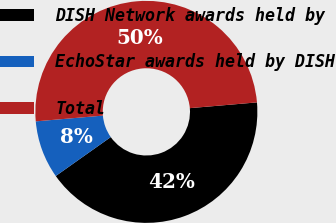Convert chart to OTSL. <chart><loc_0><loc_0><loc_500><loc_500><pie_chart><fcel>DISH Network awards held by<fcel>EchoStar awards held by DISH<fcel>Total<nl><fcel>41.56%<fcel>8.44%<fcel>50.0%<nl></chart> 